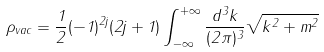Convert formula to latex. <formula><loc_0><loc_0><loc_500><loc_500>\rho _ { v a c } = \frac { 1 } { 2 } ( - 1 ) ^ { 2 j } ( 2 j + 1 ) \int _ { - \infty } ^ { + \infty } \frac { d ^ { 3 } k } { ( 2 \pi ) ^ { 3 } } \sqrt { { k } ^ { 2 } + m ^ { 2 } }</formula> 